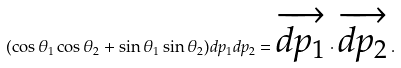<formula> <loc_0><loc_0><loc_500><loc_500>( \cos \theta _ { 1 } \cos \theta _ { 2 } + \sin \theta _ { 1 } \sin \theta _ { 2 } ) d p _ { 1 } d p _ { 2 } = \overrightarrow { d p _ { 1 } } \cdot \overrightarrow { d p _ { 2 } } \, .</formula> 